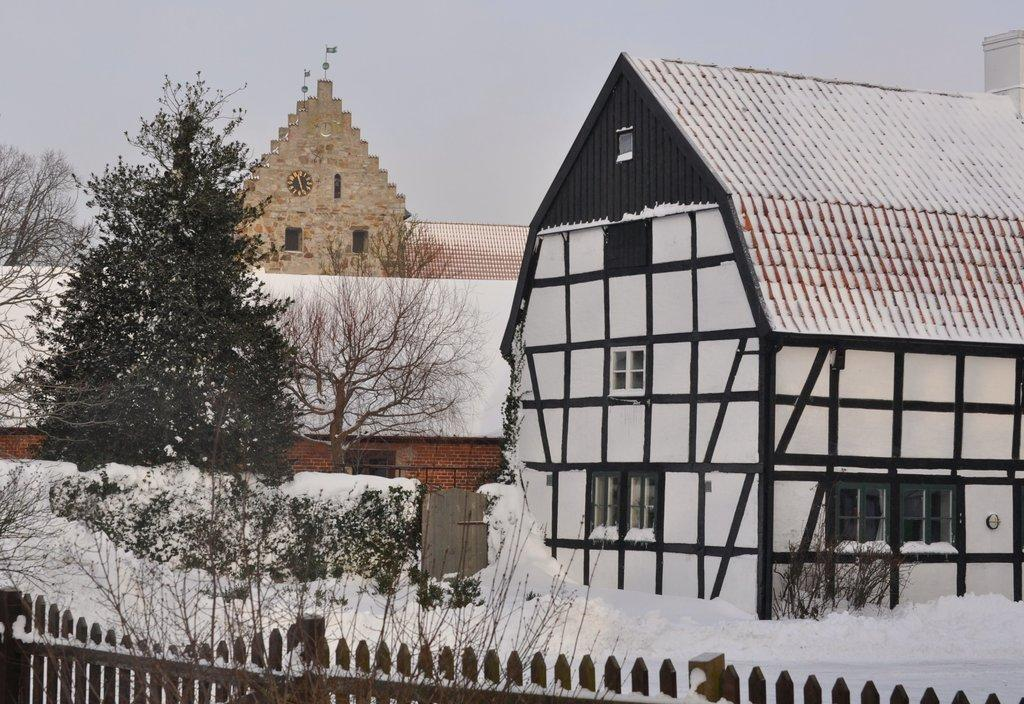What type of barrier is present in the image? There is a wooden fence in the image. What is the weather condition in the image? There is snow in the image. What type of vegetation is visible in the image? There are trees in the image. What type of structures are present in the image? There are houses in the image. What part of a building can be seen in the background of the image? There is a roof top visible in the background of the image. What other architectural feature is visible in the background of the image? There is a wall visible in the background of the image. What is visible in the sky in the background of the image? The sky is visible in the background of the image. What type of authority is depicted in the image? There is no authority figure present in the image. What fact about the street can be determined from the image? There is no street visible in the image; it features a wooden fence, snow, trees, houses, a roof top, a wall, and the sky. 